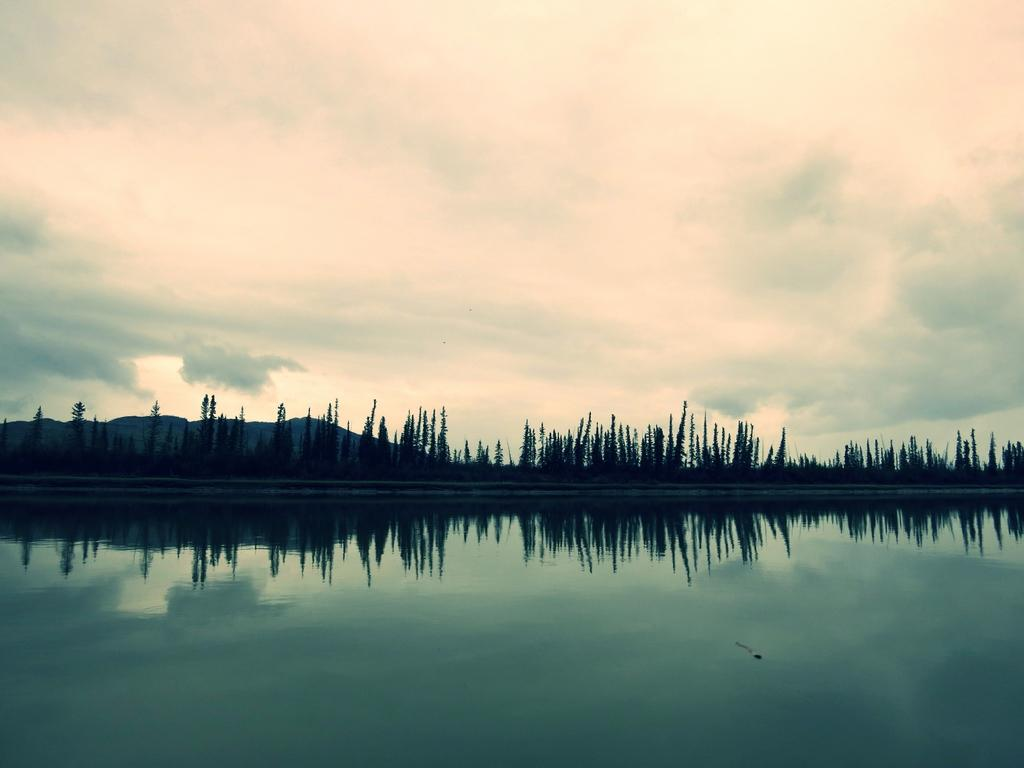What is the primary element visible in the image? There is water in the image. What type of natural features can be seen in the image? There are trees and mountains in the image. What part of the natural environment is visible in the background of the image? The sky is visible in the background of the image. How many times does the person in the image laugh during the observation? There is no person present in the image, and therefore no laughter or observation can be observed. 